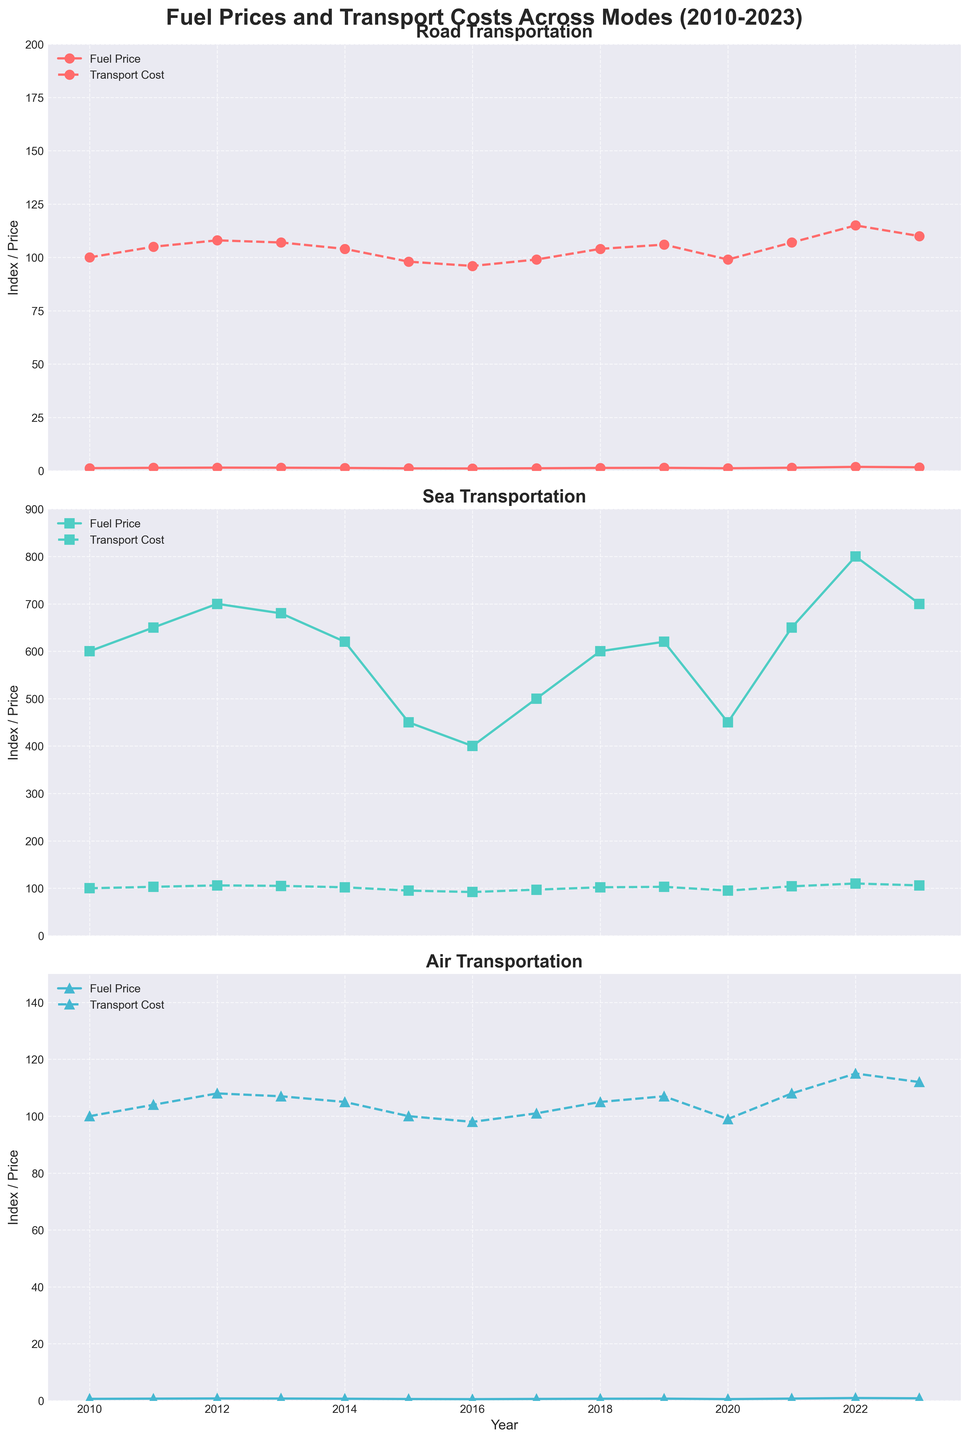What year had the highest fuel cost for road transportation? Observing the "Road Transportation" subplot, the highest point of the solid line (fuel price) occurs in 2022.
Answer: 2022 Which mode of transportation showed the most significant increase in transport cost between 2021 and 2022? Comparing the dashed lines for all three modes between 2021 and 2022 reveals the largest vertical jump in the "Sea Transportation" subplot, indicating the highest increase in transport cost.
Answer: Sea How did air fuel prices change from 2010 to 2023? By following the solid line in the "Air Transportation" subplot, we see a steady increase from 2010 to 2023.
Answer: Increased Which mode had the highest transport cost in 2022? Looking at the dashed lines for 2022, the "Sea Transportation" subplot shows the highest peak at 110.
Answer: Sea What is the difference between road transport cost and air transport cost in 2015? Locate 2015 on the x-axis for both the "Road Transportation" and "Air Transportation" subplots, and find the difference between the two dashed lines, which are at 98 and 100, respectively. The difference is 100 - 98.
Answer: 2 In which year did sea transportation costs and sea fuel prices both drop together? This can be seen where both the solid and dashed lines decrease in the "Sea Transportation" subplot, which occurs between 2014 and 2015.
Answer: 2015 How did the road transport costs change from 2016 to 2017? Follow the dashed line in the "Road Transportation" subplot from 2016 to 2017, noting it goes from 96 to 99. This indicates an increase.
Answer: Increased Which mode had the closest transport cost in 2010 and 2020? Compare the dashed lines for 2010 and 2020 in each subplot. Air transportation costs are both at approximately 100.
Answer: Air Which year saw the lowest air fuel price and what was the corresponding transport cost? Find the lowest point of the solid line in the "Air Transportation" subplot, occurring in 2016 with a price of 0.50. The corresponding transport cost (dashed line) is 98.
Answer: 2016, 98 